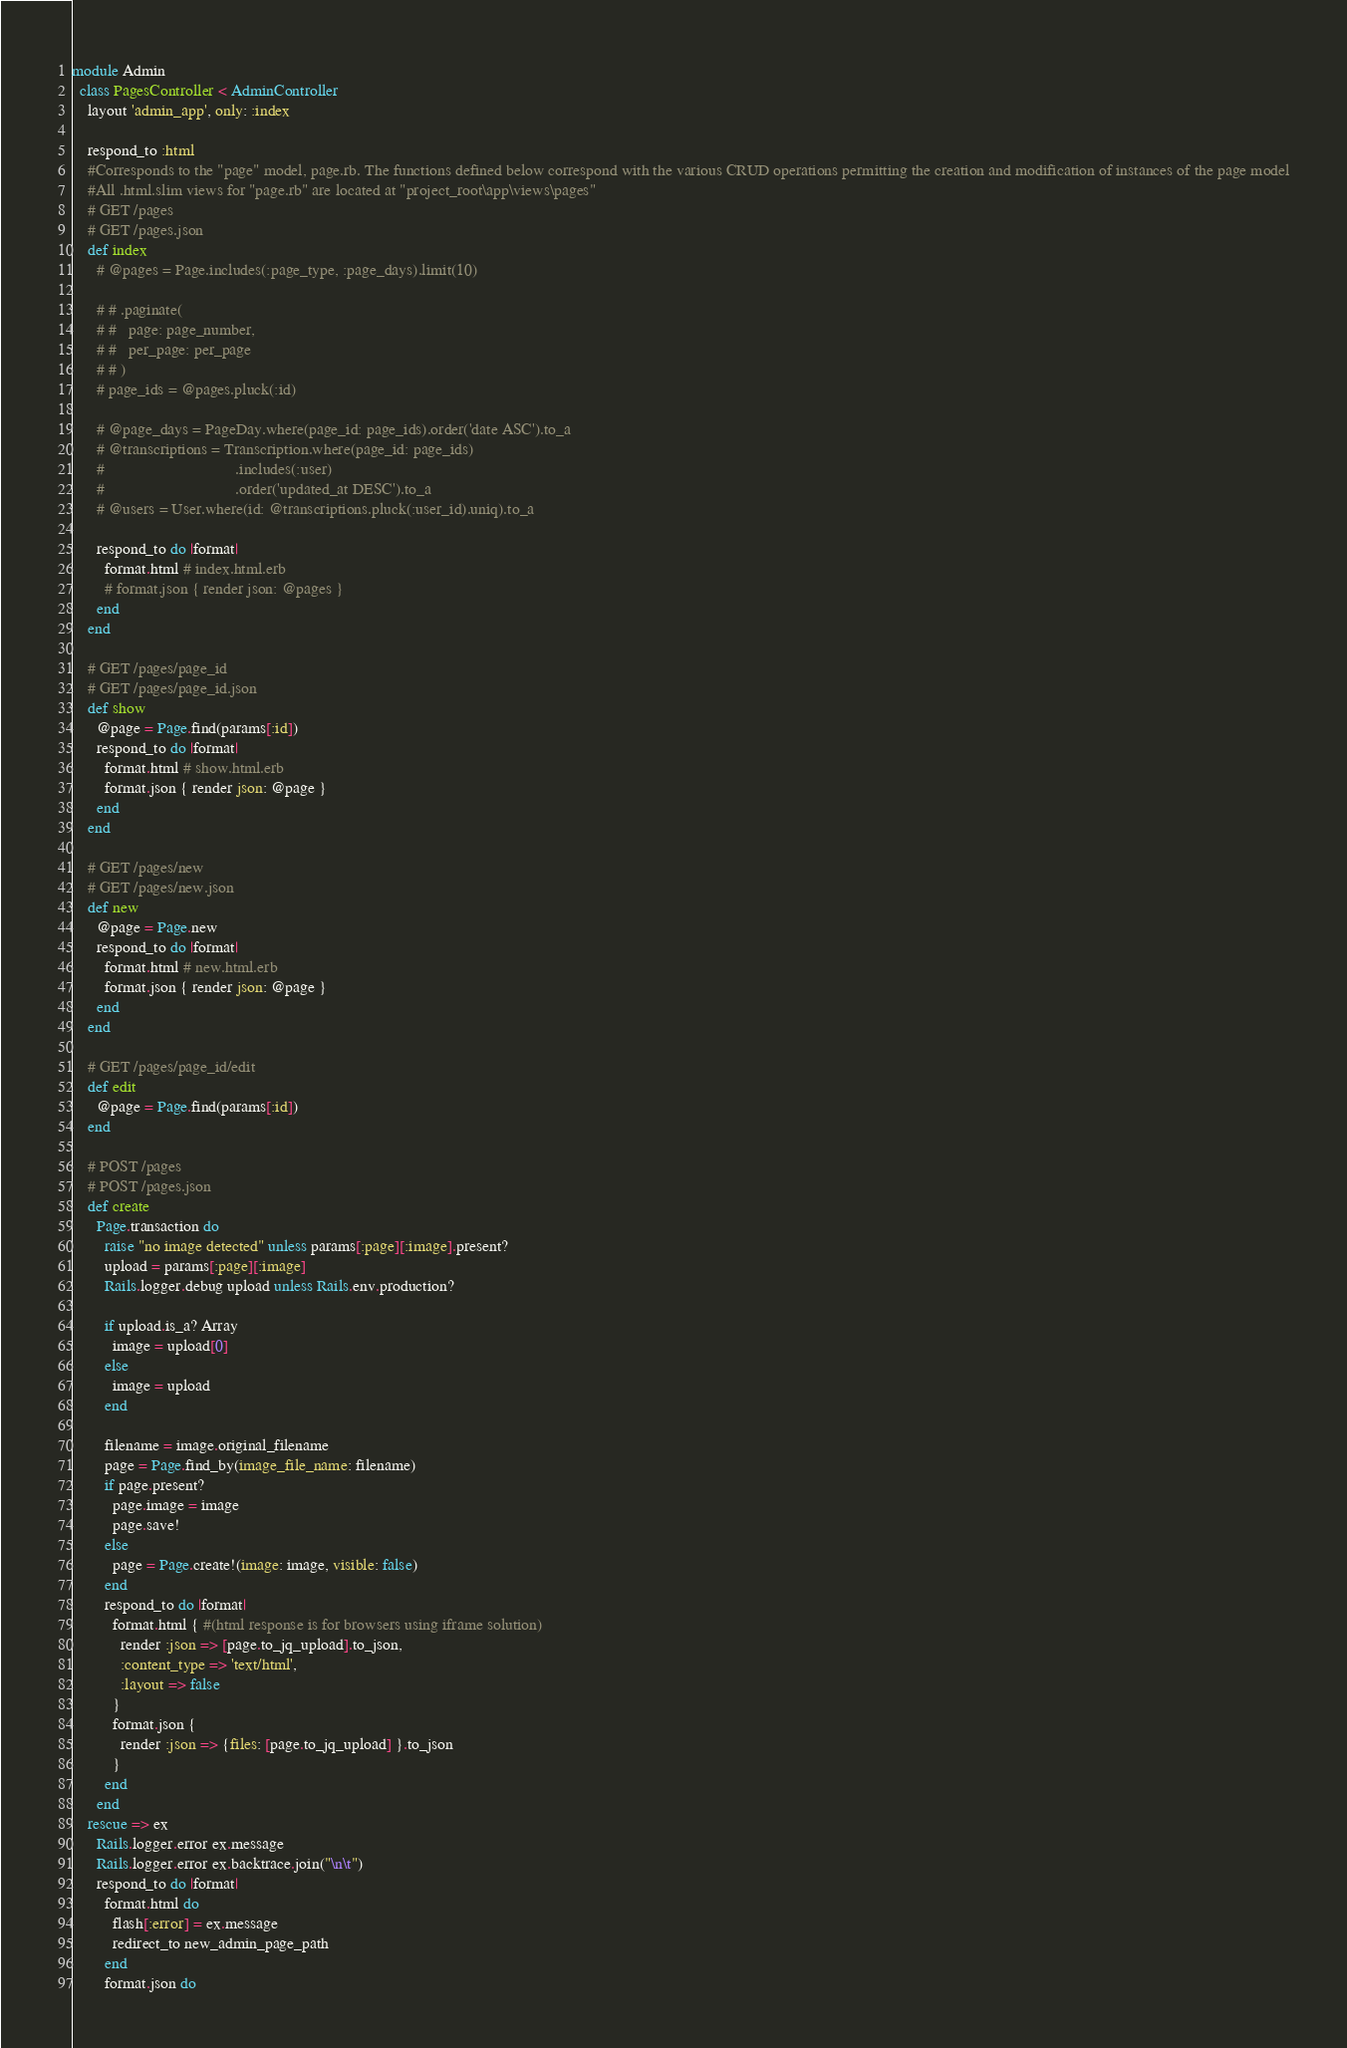<code> <loc_0><loc_0><loc_500><loc_500><_Ruby_>module Admin
  class PagesController < AdminController
    layout 'admin_app', only: :index

    respond_to :html
    #Corresponds to the "page" model, page.rb. The functions defined below correspond with the various CRUD operations permitting the creation and modification of instances of the page model
    #All .html.slim views for "page.rb" are located at "project_root\app\views\pages"
    # GET /pages
    # GET /pages.json
    def index
      # @pages = Page.includes(:page_type, :page_days).limit(10)

      # # .paginate(
      # #   page: page_number,
      # #   per_page: per_page
      # # )
      # page_ids = @pages.pluck(:id)

      # @page_days = PageDay.where(page_id: page_ids).order('date ASC').to_a
      # @transcriptions = Transcription.where(page_id: page_ids)
      #                                .includes(:user)
      #                                .order('updated_at DESC').to_a
      # @users = User.where(id: @transcriptions.pluck(:user_id).uniq).to_a

      respond_to do |format|
        format.html # index.html.erb
        # format.json { render json: @pages }
      end
    end

    # GET /pages/page_id
    # GET /pages/page_id.json
    def show
      @page = Page.find(params[:id])
      respond_to do |format|
        format.html # show.html.erb
        format.json { render json: @page }
      end
    end

    # GET /pages/new
    # GET /pages/new.json
    def new
      @page = Page.new
      respond_to do |format|
        format.html # new.html.erb
        format.json { render json: @page }
      end
    end

    # GET /pages/page_id/edit
    def edit
      @page = Page.find(params[:id])
    end

    # POST /pages
    # POST /pages.json
    def create
      Page.transaction do
        raise "no image detected" unless params[:page][:image].present?
        upload = params[:page][:image]
        Rails.logger.debug upload unless Rails.env.production?

        if upload.is_a? Array
          image = upload[0]
        else
          image = upload
        end

        filename = image.original_filename
        page = Page.find_by(image_file_name: filename)
        if page.present?
          page.image = image
          page.save!
        else
          page = Page.create!(image: image, visible: false)
        end
        respond_to do |format|
          format.html { #(html response is for browsers using iframe solution)
            render :json => [page.to_jq_upload].to_json,
            :content_type => 'text/html',
            :layout => false
          }
          format.json {
            render :json => {files: [page.to_jq_upload] }.to_json
          }
        end
      end
    rescue => ex
      Rails.logger.error ex.message
      Rails.logger.error ex.backtrace.join("\n\t")
      respond_to do |format|
        format.html do
          flash[:error] = ex.message
          redirect_to new_admin_page_path
        end
        format.json do</code> 